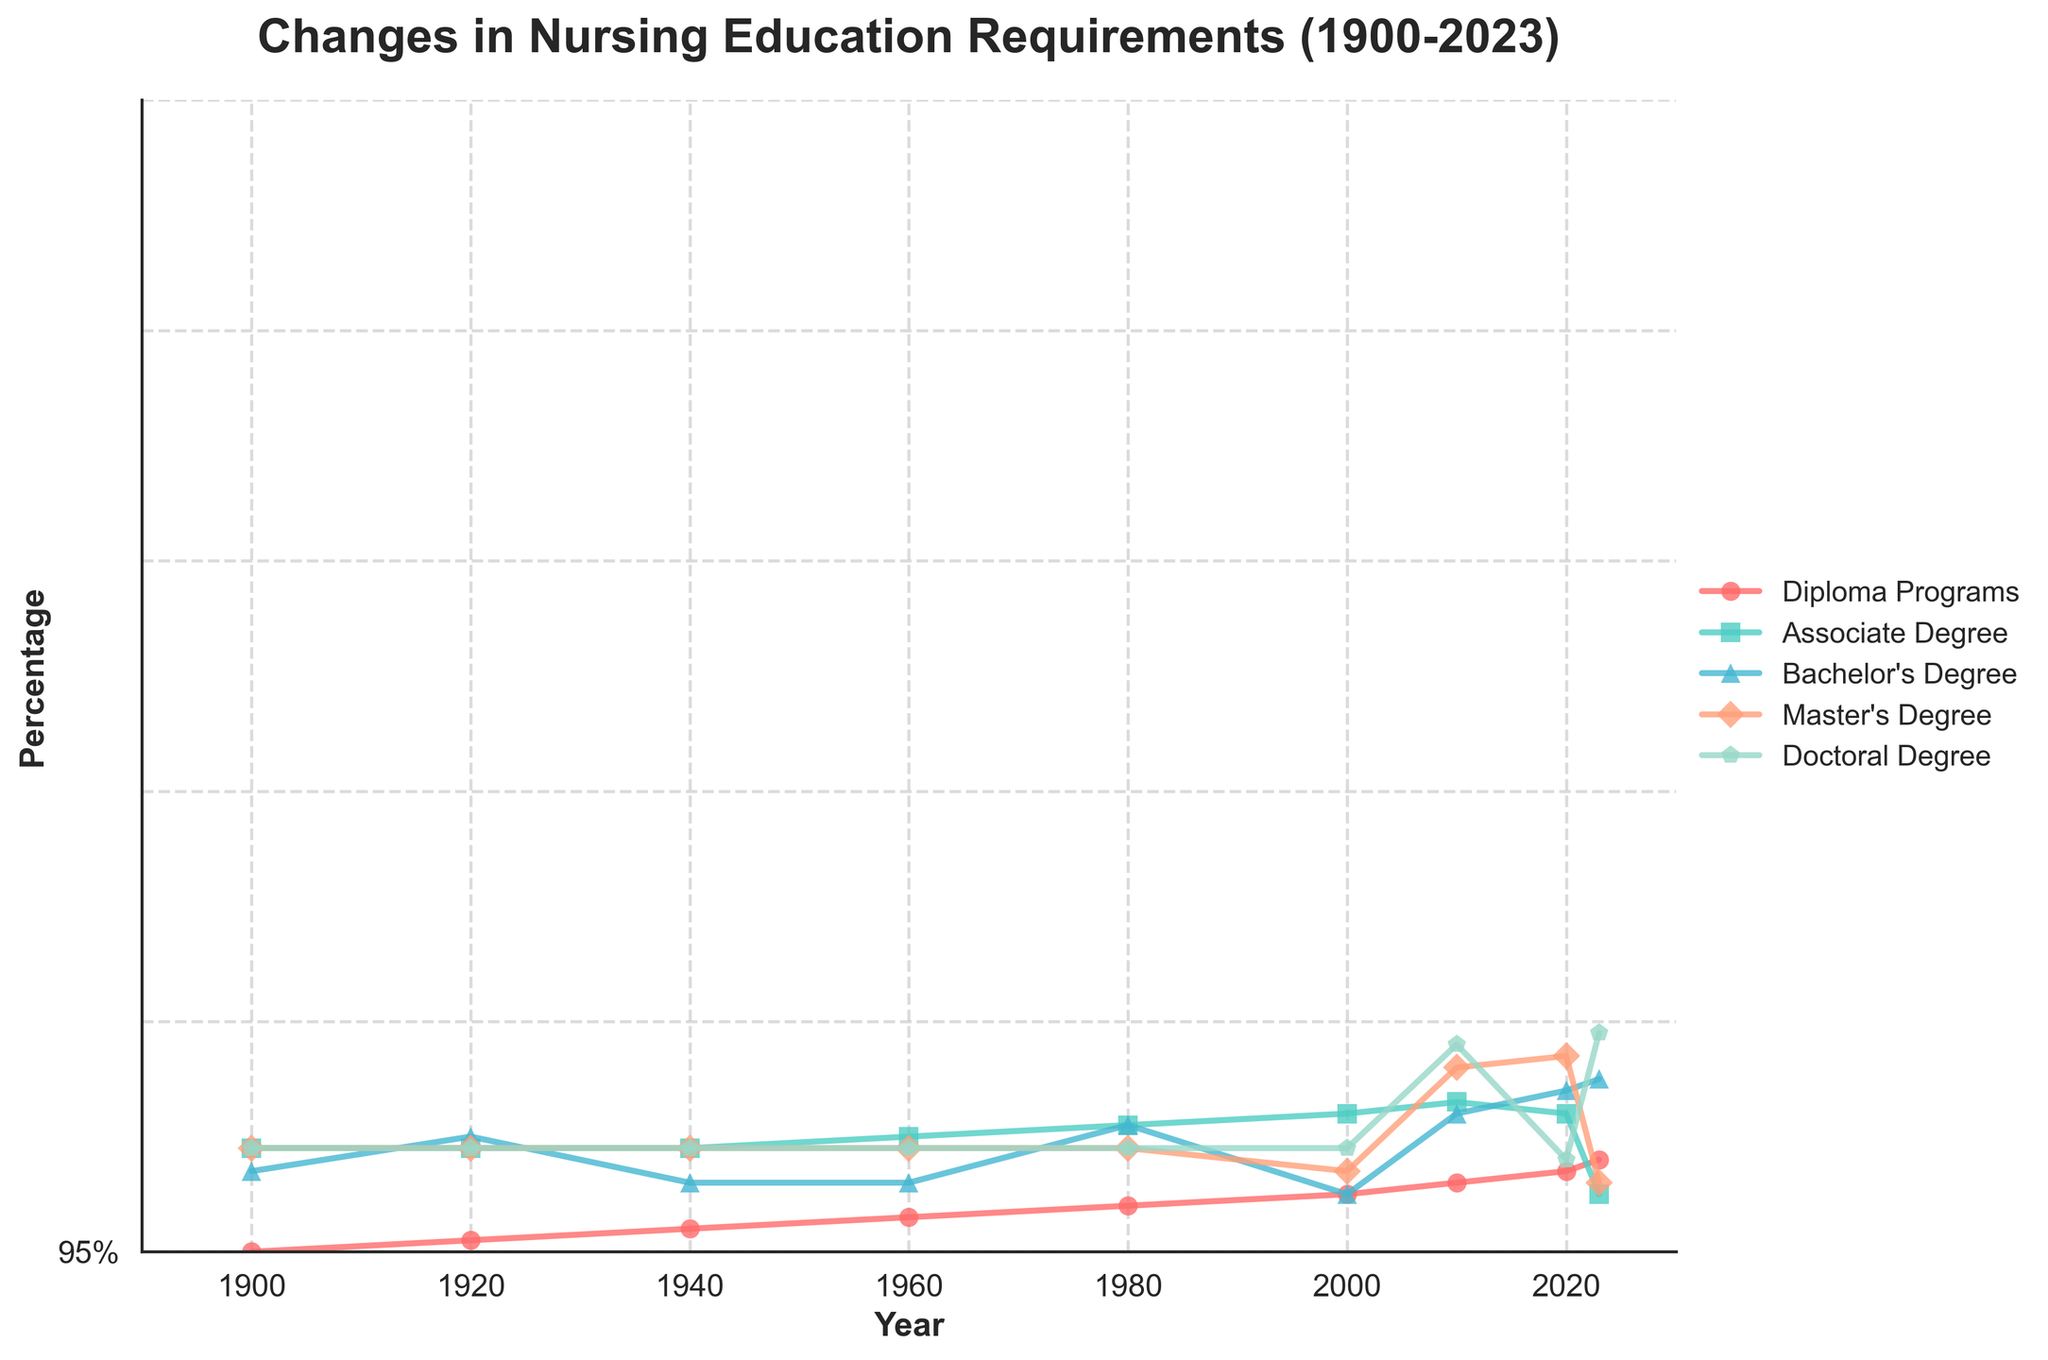How has the percentage of nurses with Diploma Programs changed from 1900 to 2023? To find the change in percentage, look at the percentages in 1900 and 2023. In 1900, 95% of nurses had Diploma Programs, and in 2023, it dropped to 2%. The percentage change is 95% - 2% = 93%.
Answer: 93% Which degree type had the greatest increase in percentage from 2000 to 2023? To determine this, calculate the differences for each degree between 2023 and 2000. For Diploma: 2% - 30% = -28%, Associate: 30% - 35% = -5%, Bachelor's: 50% - 30% = 20%, Master's: 15% - 5% = 10%, Doctoral: 3% - 0% = 3%. Bachelor's Degree shows the greatest increase of 20%.
Answer: Bachelor's Degree Compare the percentages of nurses with a Master's Degree and a Doctoral Degree in 2010. Which one is greater and by how much? In 2010, the percentages are 9% for Master's Degree and 1% for Doctoral Degree. The Master's Degree percentage is greater by 9% - 1% = 8%.
Answer: Master's Degree by 8% What is the total percentage of nurses with Diploma, Associate, and Bachelor's Degrees in 1980? To find the total percentage, add the percentages for Diploma Programs, Associate Degree, and Bachelor's Degree in 1980: 60% + 20% + 20% = 100%.
Answer: 100% Which degree type has seen a steady increase from 1960 to 2023? Observe the trend lines for all the degree types. The Bachelor's Degree shows a consistent upward trend from 1960 (15%) to 2023 (50%) without any decrease.
Answer: Bachelor's Degree What percentage of nurses had an Associate Degree in 2020, and how does this compare to the percentage in 1960? In 2020, the percentage is 35% for Associate Degree, while in 1960, it was 10%. The increase from 1960 to 2020 is 35% - 10% = 25%.
Answer: 25% By how much did the percentage of nurses with Diploma Programs decrease between 1980 and 2020? Examine the values in 1980 and 2020 for Diploma Programs. In 1980, it was 60%, and in 2020, it was 5%. The decrease is 60% - 5% = 55%.
Answer: 55% What is the average percentage of nurses with a Bachelor's Degree over the years 1940, 1960, and 2023? Add the percentages of Bachelor's Degrees for 1940 (15%), 1960 (15%), and 2023 (50%), then divide by 3. The average is (15% + 15% + 50%) / 3 = 26.67%.
Answer: 26.67% Between which two consecutive decades is there the largest increase in percentage for Master's Degrees? Compare the percentage increases between each decade: from 2000 to 2010 (9% - 5% = 4%), and from 2010 to 2020 (13% - 9% = 4%). Both 2000-2010 and 2010-2020 had the same largest increase of 4%.
Answer: 2000-2010 and 2010-2020 What is the sum of the percentages for Bachelor's, Master's, and Doctoral Degrees in 2023? Add the percentages for Bachelor's (50%), Master's (15%), and Doctoral (3%) in 2023: 50% + 15% + 3% = 68%.
Answer: 68% 